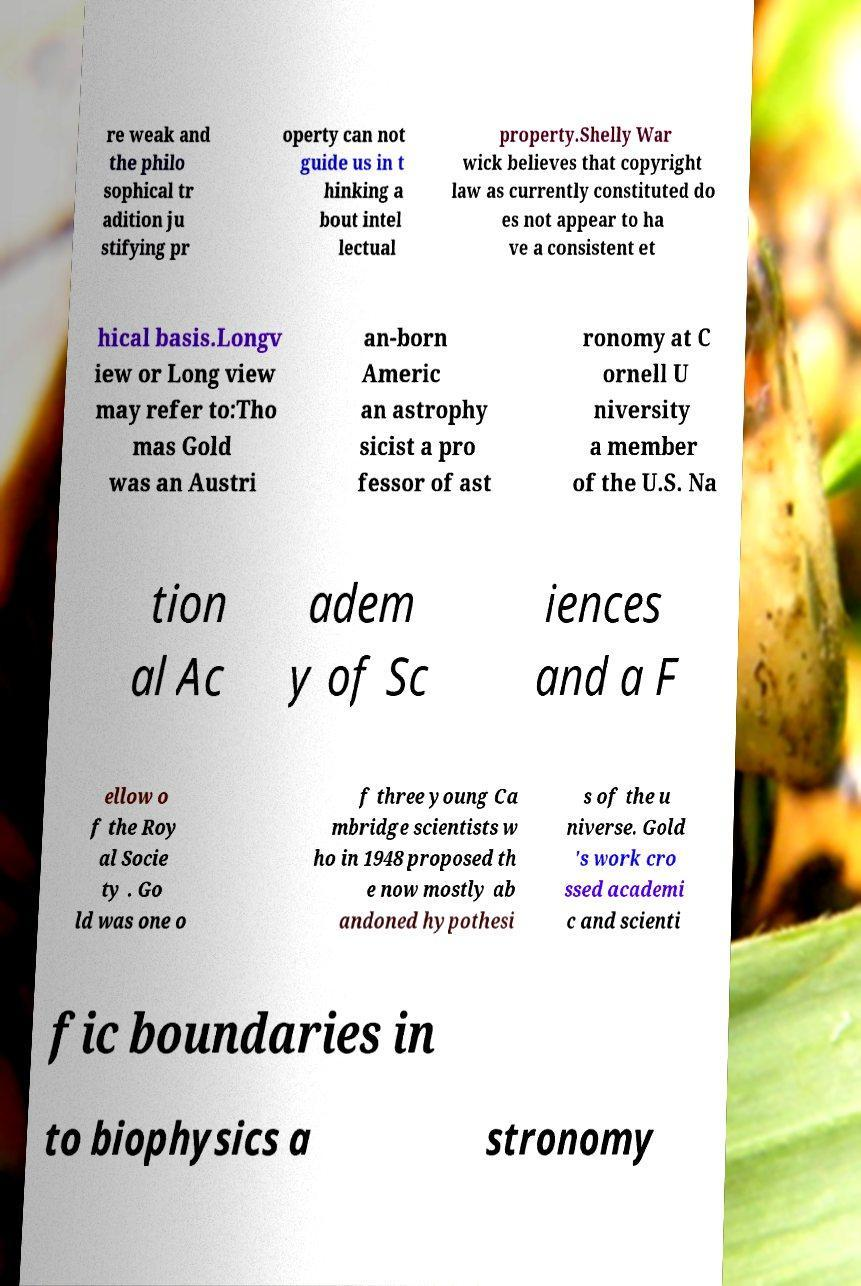Can you accurately transcribe the text from the provided image for me? re weak and the philo sophical tr adition ju stifying pr operty can not guide us in t hinking a bout intel lectual property.Shelly War wick believes that copyright law as currently constituted do es not appear to ha ve a consistent et hical basis.Longv iew or Long view may refer to:Tho mas Gold was an Austri an-born Americ an astrophy sicist a pro fessor of ast ronomy at C ornell U niversity a member of the U.S. Na tion al Ac adem y of Sc iences and a F ellow o f the Roy al Socie ty . Go ld was one o f three young Ca mbridge scientists w ho in 1948 proposed th e now mostly ab andoned hypothesi s of the u niverse. Gold 's work cro ssed academi c and scienti fic boundaries in to biophysics a stronomy 